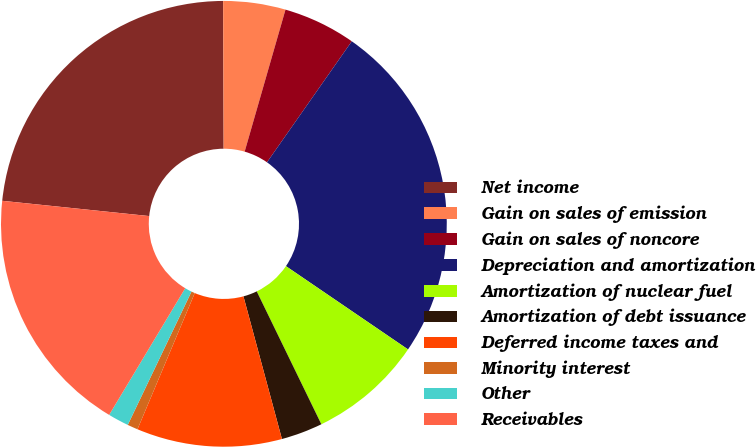Convert chart. <chart><loc_0><loc_0><loc_500><loc_500><pie_chart><fcel>Net income<fcel>Gain on sales of emission<fcel>Gain on sales of noncore<fcel>Depreciation and amortization<fcel>Amortization of nuclear fuel<fcel>Amortization of debt issuance<fcel>Deferred income taxes and<fcel>Minority interest<fcel>Other<fcel>Receivables<nl><fcel>23.3%<fcel>4.51%<fcel>5.27%<fcel>24.8%<fcel>8.27%<fcel>3.01%<fcel>10.53%<fcel>0.76%<fcel>1.51%<fcel>18.04%<nl></chart> 